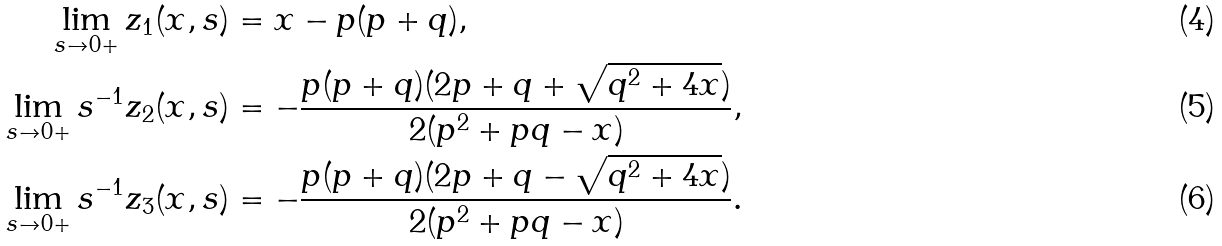Convert formula to latex. <formula><loc_0><loc_0><loc_500><loc_500>\lim _ { s \to 0 + } z _ { 1 } ( x , s ) & = x - p ( p + q ) , \\ \lim _ { s \to 0 + } s ^ { - 1 } z _ { 2 } ( x , s ) & = - \frac { p ( p + q ) ( 2 p + q + \sqrt { q ^ { 2 } + 4 x } ) } { 2 ( p ^ { 2 } + p q - x ) } , \\ \lim _ { s \to 0 + } s ^ { - 1 } z _ { 3 } ( x , s ) & = - \frac { p ( p + q ) ( 2 p + q - \sqrt { q ^ { 2 } + 4 x } ) } { 2 ( p ^ { 2 } + p q - x ) } .</formula> 